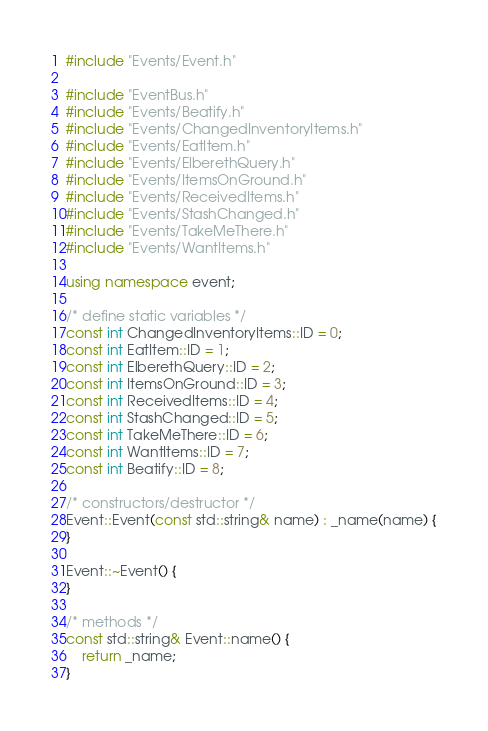Convert code to text. <code><loc_0><loc_0><loc_500><loc_500><_C++_>#include "Events/Event.h"

#include "EventBus.h"
#include "Events/Beatify.h"
#include "Events/ChangedInventoryItems.h"
#include "Events/EatItem.h"
#include "Events/ElberethQuery.h"
#include "Events/ItemsOnGround.h"
#include "Events/ReceivedItems.h"
#include "Events/StashChanged.h"
#include "Events/TakeMeThere.h"
#include "Events/WantItems.h"

using namespace event;

/* define static variables */
const int ChangedInventoryItems::ID = 0;
const int EatItem::ID = 1;
const int ElberethQuery::ID = 2;
const int ItemsOnGround::ID = 3;
const int ReceivedItems::ID = 4;
const int StashChanged::ID = 5;
const int TakeMeThere::ID = 6;
const int WantItems::ID = 7;
const int Beatify::ID = 8;

/* constructors/destructor */
Event::Event(const std::string& name) : _name(name) {
}

Event::~Event() {
}

/* methods */
const std::string& Event::name() {
	return _name;
}
</code> 